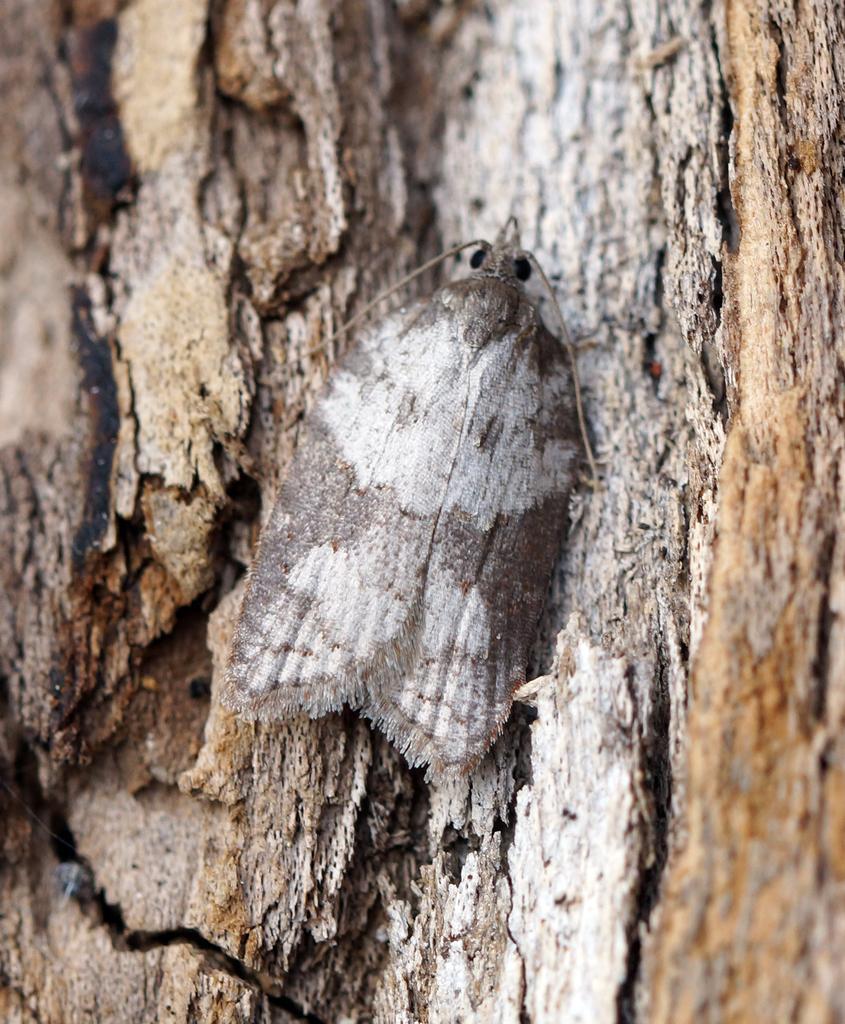How would you summarize this image in a sentence or two? As we can see in the image there is a tree stem and an insect. 